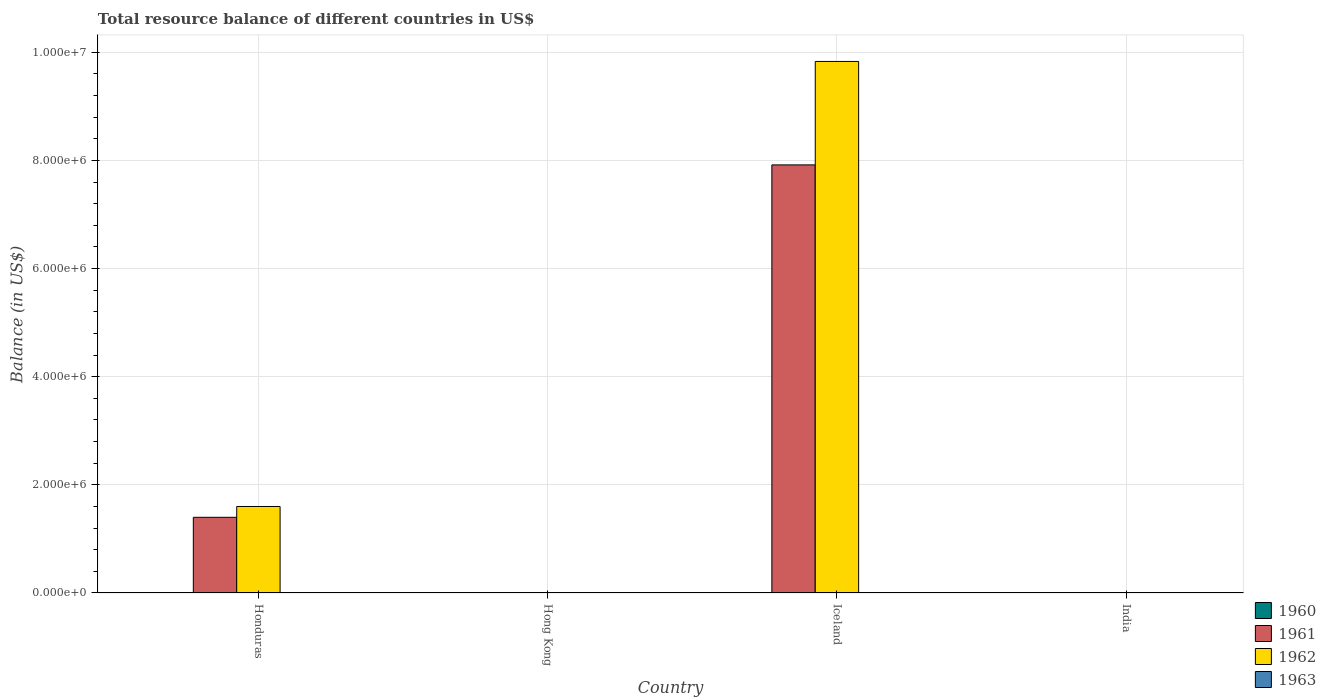Are the number of bars per tick equal to the number of legend labels?
Your answer should be very brief. No. How many bars are there on the 1st tick from the left?
Offer a very short reply. 2. What is the total resource balance in 1962 in Honduras?
Provide a succinct answer. 1.60e+06. Across all countries, what is the maximum total resource balance in 1962?
Give a very brief answer. 9.83e+06. In which country was the total resource balance in 1961 maximum?
Provide a short and direct response. Iceland. What is the difference between the total resource balance in 1962 in Iceland and the total resource balance in 1961 in Hong Kong?
Your answer should be compact. 9.83e+06. What is the difference between the total resource balance of/in 1962 and total resource balance of/in 1961 in Honduras?
Offer a terse response. 2.00e+05. In how many countries, is the total resource balance in 1960 greater than 3200000 US$?
Offer a terse response. 0. What is the ratio of the total resource balance in 1962 in Honduras to that in Iceland?
Provide a succinct answer. 0.16. Is the total resource balance in 1961 in Honduras less than that in Iceland?
Provide a short and direct response. Yes. What is the difference between the highest and the lowest total resource balance in 1962?
Give a very brief answer. 9.83e+06. Is it the case that in every country, the sum of the total resource balance in 1963 and total resource balance in 1960 is greater than the sum of total resource balance in 1961 and total resource balance in 1962?
Your response must be concise. No. Are all the bars in the graph horizontal?
Provide a short and direct response. No. How many countries are there in the graph?
Make the answer very short. 4. Are the values on the major ticks of Y-axis written in scientific E-notation?
Ensure brevity in your answer.  Yes. What is the title of the graph?
Keep it short and to the point. Total resource balance of different countries in US$. What is the label or title of the X-axis?
Provide a short and direct response. Country. What is the label or title of the Y-axis?
Offer a very short reply. Balance (in US$). What is the Balance (in US$) in 1960 in Honduras?
Provide a succinct answer. 0. What is the Balance (in US$) in 1961 in Honduras?
Make the answer very short. 1.40e+06. What is the Balance (in US$) in 1962 in Honduras?
Ensure brevity in your answer.  1.60e+06. What is the Balance (in US$) in 1963 in Honduras?
Your answer should be compact. 0. What is the Balance (in US$) in 1963 in Hong Kong?
Provide a short and direct response. 0. What is the Balance (in US$) of 1960 in Iceland?
Offer a very short reply. 0. What is the Balance (in US$) in 1961 in Iceland?
Make the answer very short. 7.92e+06. What is the Balance (in US$) of 1962 in Iceland?
Ensure brevity in your answer.  9.83e+06. What is the Balance (in US$) in 1960 in India?
Ensure brevity in your answer.  0. What is the Balance (in US$) in 1961 in India?
Your answer should be very brief. 0. What is the Balance (in US$) in 1963 in India?
Give a very brief answer. 0. Across all countries, what is the maximum Balance (in US$) in 1961?
Provide a succinct answer. 7.92e+06. Across all countries, what is the maximum Balance (in US$) in 1962?
Provide a succinct answer. 9.83e+06. What is the total Balance (in US$) in 1960 in the graph?
Provide a short and direct response. 0. What is the total Balance (in US$) of 1961 in the graph?
Provide a succinct answer. 9.32e+06. What is the total Balance (in US$) in 1962 in the graph?
Your answer should be compact. 1.14e+07. What is the difference between the Balance (in US$) in 1961 in Honduras and that in Iceland?
Offer a terse response. -6.52e+06. What is the difference between the Balance (in US$) of 1962 in Honduras and that in Iceland?
Make the answer very short. -8.23e+06. What is the difference between the Balance (in US$) in 1961 in Honduras and the Balance (in US$) in 1962 in Iceland?
Provide a succinct answer. -8.43e+06. What is the average Balance (in US$) in 1961 per country?
Provide a succinct answer. 2.33e+06. What is the average Balance (in US$) of 1962 per country?
Give a very brief answer. 2.86e+06. What is the difference between the Balance (in US$) of 1961 and Balance (in US$) of 1962 in Honduras?
Make the answer very short. -2.00e+05. What is the difference between the Balance (in US$) of 1961 and Balance (in US$) of 1962 in Iceland?
Provide a succinct answer. -1.91e+06. What is the ratio of the Balance (in US$) of 1961 in Honduras to that in Iceland?
Your answer should be very brief. 0.18. What is the ratio of the Balance (in US$) of 1962 in Honduras to that in Iceland?
Keep it short and to the point. 0.16. What is the difference between the highest and the lowest Balance (in US$) of 1961?
Your answer should be compact. 7.92e+06. What is the difference between the highest and the lowest Balance (in US$) in 1962?
Give a very brief answer. 9.83e+06. 